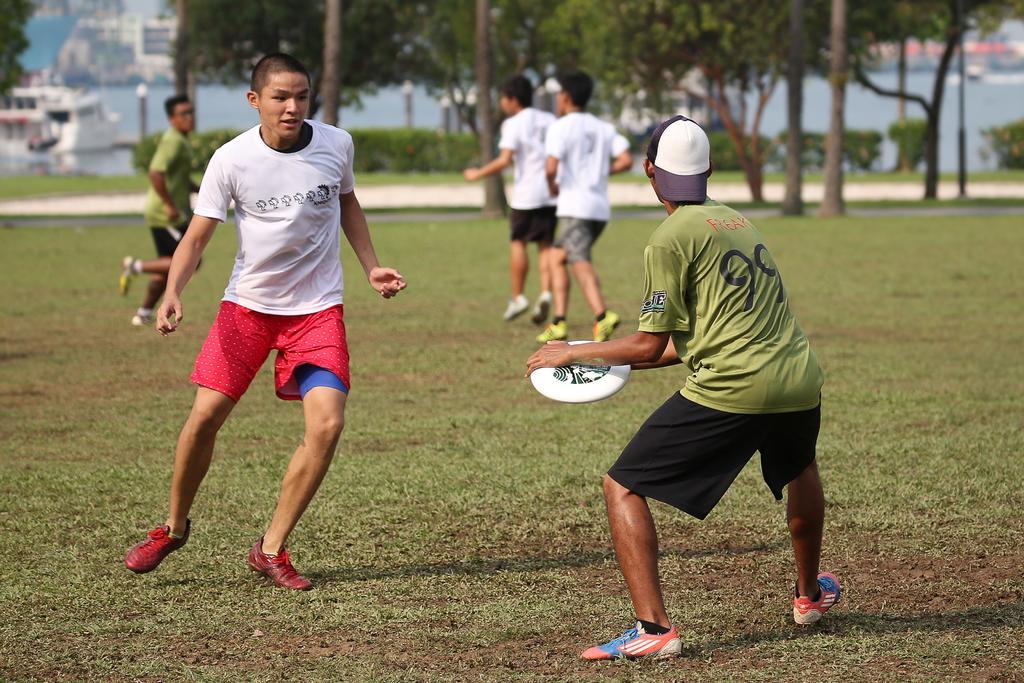Please provide a concise description of this image. In the foreground of the picture we can see two men playing. At the bottom there is grass. In the middle there are people. In the background we can see trees, plants, grass, buildings and other objects. 